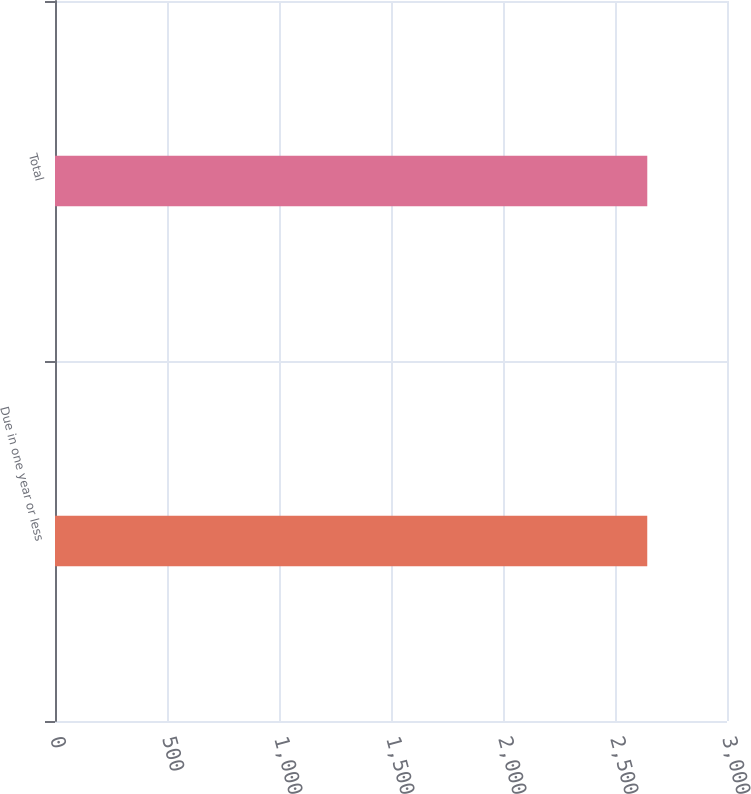Convert chart to OTSL. <chart><loc_0><loc_0><loc_500><loc_500><bar_chart><fcel>Due in one year or less<fcel>Total<nl><fcel>2644<fcel>2644.1<nl></chart> 